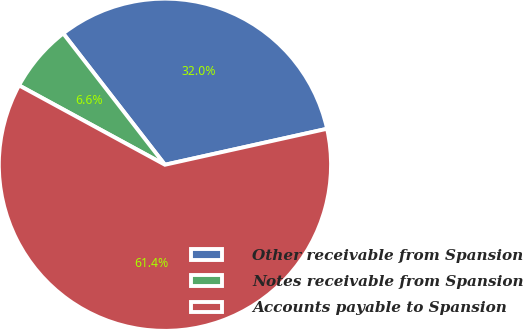<chart> <loc_0><loc_0><loc_500><loc_500><pie_chart><fcel>Other receivable from Spansion<fcel>Notes receivable from Spansion<fcel>Accounts payable to Spansion<nl><fcel>32.01%<fcel>6.58%<fcel>61.4%<nl></chart> 